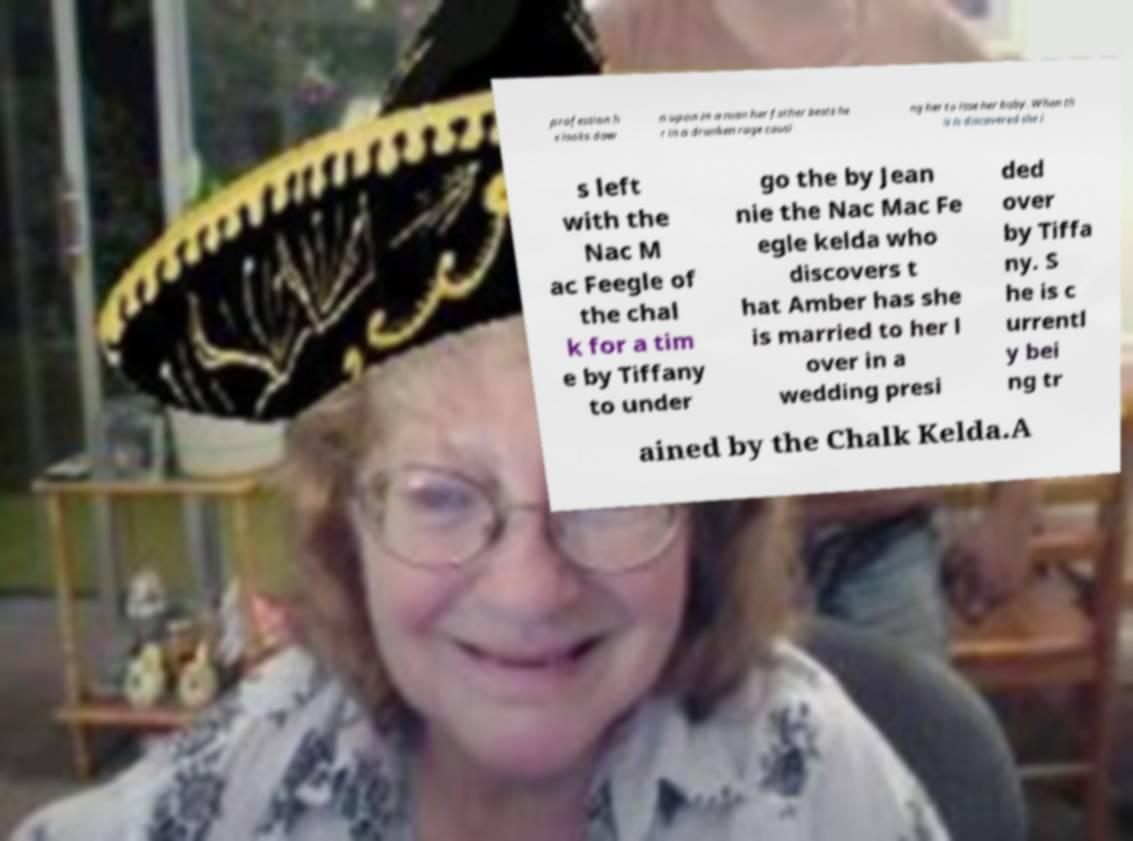Could you extract and type out the text from this image? profession h e looks dow n upon in a man her father beats he r in a drunken rage causi ng her to lose her baby. When th is is discovered she i s left with the Nac M ac Feegle of the chal k for a tim e by Tiffany to under go the by Jean nie the Nac Mac Fe egle kelda who discovers t hat Amber has she is married to her l over in a wedding presi ded over by Tiffa ny. S he is c urrentl y bei ng tr ained by the Chalk Kelda.A 